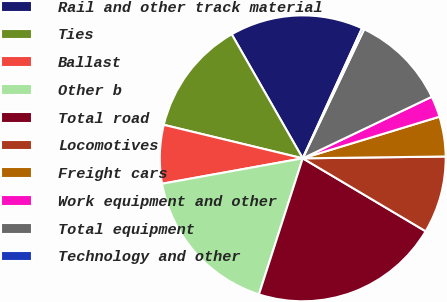Convert chart to OTSL. <chart><loc_0><loc_0><loc_500><loc_500><pie_chart><fcel>Rail and other track material<fcel>Ties<fcel>Ballast<fcel>Other b<fcel>Total road<fcel>Locomotives<fcel>Freight cars<fcel>Work equipment and other<fcel>Total equipment<fcel>Technology and other<nl><fcel>15.08%<fcel>12.96%<fcel>6.61%<fcel>17.2%<fcel>21.43%<fcel>8.73%<fcel>4.5%<fcel>2.38%<fcel>10.85%<fcel>0.26%<nl></chart> 